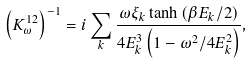<formula> <loc_0><loc_0><loc_500><loc_500>\left ( K ^ { 1 2 } _ { \omega } \right ) ^ { - 1 } = i \sum _ { k } \frac { \omega \xi _ { k } \tanh { \left ( \beta E _ { k } / 2 \right ) } } { 4 E ^ { 3 } _ { k } \left ( 1 - \omega ^ { 2 } / 4 E ^ { 2 } _ { k } \right ) } ,</formula> 